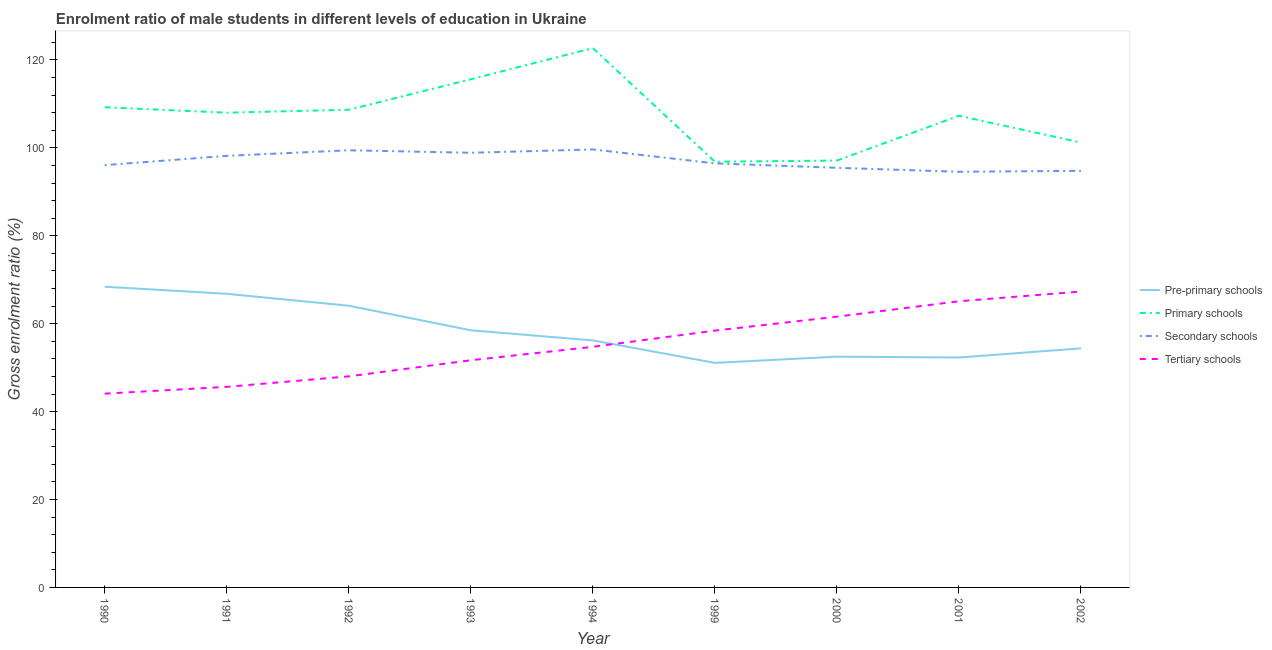Does the line corresponding to gross enrolment ratio(female) in primary schools intersect with the line corresponding to gross enrolment ratio(female) in tertiary schools?
Your answer should be compact. No. What is the gross enrolment ratio(female) in tertiary schools in 2001?
Provide a short and direct response. 65.1. Across all years, what is the maximum gross enrolment ratio(female) in secondary schools?
Ensure brevity in your answer.  99.64. Across all years, what is the minimum gross enrolment ratio(female) in tertiary schools?
Give a very brief answer. 44.09. What is the total gross enrolment ratio(female) in pre-primary schools in the graph?
Your response must be concise. 524.3. What is the difference between the gross enrolment ratio(female) in pre-primary schools in 1990 and that in 1993?
Keep it short and to the point. 9.91. What is the difference between the gross enrolment ratio(female) in tertiary schools in 1992 and the gross enrolment ratio(female) in primary schools in 1991?
Your answer should be very brief. -59.99. What is the average gross enrolment ratio(female) in primary schools per year?
Your response must be concise. 107.41. In the year 1993, what is the difference between the gross enrolment ratio(female) in tertiary schools and gross enrolment ratio(female) in primary schools?
Provide a short and direct response. -63.92. What is the ratio of the gross enrolment ratio(female) in secondary schools in 1991 to that in 2002?
Provide a succinct answer. 1.04. What is the difference between the highest and the second highest gross enrolment ratio(female) in secondary schools?
Your answer should be compact. 0.19. What is the difference between the highest and the lowest gross enrolment ratio(female) in secondary schools?
Your answer should be compact. 5.08. Is it the case that in every year, the sum of the gross enrolment ratio(female) in primary schools and gross enrolment ratio(female) in tertiary schools is greater than the sum of gross enrolment ratio(female) in pre-primary schools and gross enrolment ratio(female) in secondary schools?
Your answer should be compact. Yes. Is the gross enrolment ratio(female) in pre-primary schools strictly greater than the gross enrolment ratio(female) in tertiary schools over the years?
Provide a short and direct response. No. Is the gross enrolment ratio(female) in tertiary schools strictly less than the gross enrolment ratio(female) in pre-primary schools over the years?
Keep it short and to the point. No. How many lines are there?
Provide a short and direct response. 4. How many years are there in the graph?
Your response must be concise. 9. Are the values on the major ticks of Y-axis written in scientific E-notation?
Offer a very short reply. No. Does the graph contain any zero values?
Ensure brevity in your answer.  No. How many legend labels are there?
Give a very brief answer. 4. What is the title of the graph?
Your answer should be compact. Enrolment ratio of male students in different levels of education in Ukraine. Does "Labor Taxes" appear as one of the legend labels in the graph?
Keep it short and to the point. No. What is the label or title of the X-axis?
Offer a terse response. Year. What is the Gross enrolment ratio (%) of Pre-primary schools in 1990?
Provide a short and direct response. 68.42. What is the Gross enrolment ratio (%) of Primary schools in 1990?
Offer a very short reply. 109.24. What is the Gross enrolment ratio (%) of Secondary schools in 1990?
Offer a terse response. 96.07. What is the Gross enrolment ratio (%) of Tertiary schools in 1990?
Provide a succinct answer. 44.09. What is the Gross enrolment ratio (%) in Pre-primary schools in 1991?
Provide a short and direct response. 66.8. What is the Gross enrolment ratio (%) of Primary schools in 1991?
Ensure brevity in your answer.  108.01. What is the Gross enrolment ratio (%) in Secondary schools in 1991?
Provide a succinct answer. 98.19. What is the Gross enrolment ratio (%) in Tertiary schools in 1991?
Provide a succinct answer. 45.63. What is the Gross enrolment ratio (%) of Pre-primary schools in 1992?
Ensure brevity in your answer.  64.09. What is the Gross enrolment ratio (%) of Primary schools in 1992?
Ensure brevity in your answer.  108.67. What is the Gross enrolment ratio (%) in Secondary schools in 1992?
Your response must be concise. 99.45. What is the Gross enrolment ratio (%) in Tertiary schools in 1992?
Provide a succinct answer. 48.02. What is the Gross enrolment ratio (%) in Pre-primary schools in 1993?
Make the answer very short. 58.5. What is the Gross enrolment ratio (%) in Primary schools in 1993?
Your response must be concise. 115.6. What is the Gross enrolment ratio (%) in Secondary schools in 1993?
Your response must be concise. 98.89. What is the Gross enrolment ratio (%) of Tertiary schools in 1993?
Provide a succinct answer. 51.68. What is the Gross enrolment ratio (%) in Pre-primary schools in 1994?
Keep it short and to the point. 56.2. What is the Gross enrolment ratio (%) of Primary schools in 1994?
Keep it short and to the point. 122.7. What is the Gross enrolment ratio (%) in Secondary schools in 1994?
Your response must be concise. 99.64. What is the Gross enrolment ratio (%) of Tertiary schools in 1994?
Offer a very short reply. 54.74. What is the Gross enrolment ratio (%) in Pre-primary schools in 1999?
Your response must be concise. 51.09. What is the Gross enrolment ratio (%) of Primary schools in 1999?
Keep it short and to the point. 96.86. What is the Gross enrolment ratio (%) of Secondary schools in 1999?
Ensure brevity in your answer.  96.48. What is the Gross enrolment ratio (%) of Tertiary schools in 1999?
Your answer should be very brief. 58.43. What is the Gross enrolment ratio (%) in Pre-primary schools in 2000?
Keep it short and to the point. 52.5. What is the Gross enrolment ratio (%) of Primary schools in 2000?
Your answer should be compact. 97.11. What is the Gross enrolment ratio (%) in Secondary schools in 2000?
Provide a short and direct response. 95.46. What is the Gross enrolment ratio (%) in Tertiary schools in 2000?
Make the answer very short. 61.6. What is the Gross enrolment ratio (%) in Pre-primary schools in 2001?
Your response must be concise. 52.31. What is the Gross enrolment ratio (%) of Primary schools in 2001?
Your answer should be very brief. 107.3. What is the Gross enrolment ratio (%) in Secondary schools in 2001?
Your answer should be very brief. 94.56. What is the Gross enrolment ratio (%) in Tertiary schools in 2001?
Keep it short and to the point. 65.1. What is the Gross enrolment ratio (%) in Pre-primary schools in 2002?
Provide a succinct answer. 54.39. What is the Gross enrolment ratio (%) in Primary schools in 2002?
Offer a terse response. 101.22. What is the Gross enrolment ratio (%) of Secondary schools in 2002?
Keep it short and to the point. 94.78. What is the Gross enrolment ratio (%) in Tertiary schools in 2002?
Provide a succinct answer. 67.32. Across all years, what is the maximum Gross enrolment ratio (%) in Pre-primary schools?
Make the answer very short. 68.42. Across all years, what is the maximum Gross enrolment ratio (%) in Primary schools?
Provide a short and direct response. 122.7. Across all years, what is the maximum Gross enrolment ratio (%) of Secondary schools?
Ensure brevity in your answer.  99.64. Across all years, what is the maximum Gross enrolment ratio (%) in Tertiary schools?
Make the answer very short. 67.32. Across all years, what is the minimum Gross enrolment ratio (%) in Pre-primary schools?
Ensure brevity in your answer.  51.09. Across all years, what is the minimum Gross enrolment ratio (%) in Primary schools?
Give a very brief answer. 96.86. Across all years, what is the minimum Gross enrolment ratio (%) of Secondary schools?
Provide a succinct answer. 94.56. Across all years, what is the minimum Gross enrolment ratio (%) in Tertiary schools?
Give a very brief answer. 44.09. What is the total Gross enrolment ratio (%) in Pre-primary schools in the graph?
Your response must be concise. 524.3. What is the total Gross enrolment ratio (%) in Primary schools in the graph?
Provide a short and direct response. 966.7. What is the total Gross enrolment ratio (%) in Secondary schools in the graph?
Provide a short and direct response. 873.52. What is the total Gross enrolment ratio (%) in Tertiary schools in the graph?
Provide a short and direct response. 496.6. What is the difference between the Gross enrolment ratio (%) in Pre-primary schools in 1990 and that in 1991?
Provide a short and direct response. 1.62. What is the difference between the Gross enrolment ratio (%) of Primary schools in 1990 and that in 1991?
Offer a terse response. 1.23. What is the difference between the Gross enrolment ratio (%) in Secondary schools in 1990 and that in 1991?
Make the answer very short. -2.12. What is the difference between the Gross enrolment ratio (%) in Tertiary schools in 1990 and that in 1991?
Ensure brevity in your answer.  -1.54. What is the difference between the Gross enrolment ratio (%) of Pre-primary schools in 1990 and that in 1992?
Ensure brevity in your answer.  4.33. What is the difference between the Gross enrolment ratio (%) in Primary schools in 1990 and that in 1992?
Keep it short and to the point. 0.57. What is the difference between the Gross enrolment ratio (%) of Secondary schools in 1990 and that in 1992?
Give a very brief answer. -3.38. What is the difference between the Gross enrolment ratio (%) of Tertiary schools in 1990 and that in 1992?
Ensure brevity in your answer.  -3.93. What is the difference between the Gross enrolment ratio (%) of Pre-primary schools in 1990 and that in 1993?
Your response must be concise. 9.91. What is the difference between the Gross enrolment ratio (%) of Primary schools in 1990 and that in 1993?
Your answer should be compact. -6.37. What is the difference between the Gross enrolment ratio (%) in Secondary schools in 1990 and that in 1993?
Your answer should be very brief. -2.82. What is the difference between the Gross enrolment ratio (%) of Tertiary schools in 1990 and that in 1993?
Keep it short and to the point. -7.6. What is the difference between the Gross enrolment ratio (%) in Pre-primary schools in 1990 and that in 1994?
Offer a very short reply. 12.21. What is the difference between the Gross enrolment ratio (%) of Primary schools in 1990 and that in 1994?
Provide a short and direct response. -13.46. What is the difference between the Gross enrolment ratio (%) of Secondary schools in 1990 and that in 1994?
Ensure brevity in your answer.  -3.57. What is the difference between the Gross enrolment ratio (%) in Tertiary schools in 1990 and that in 1994?
Your answer should be compact. -10.65. What is the difference between the Gross enrolment ratio (%) of Pre-primary schools in 1990 and that in 1999?
Offer a very short reply. 17.33. What is the difference between the Gross enrolment ratio (%) of Primary schools in 1990 and that in 1999?
Provide a short and direct response. 12.38. What is the difference between the Gross enrolment ratio (%) of Secondary schools in 1990 and that in 1999?
Provide a succinct answer. -0.41. What is the difference between the Gross enrolment ratio (%) in Tertiary schools in 1990 and that in 1999?
Make the answer very short. -14.34. What is the difference between the Gross enrolment ratio (%) of Pre-primary schools in 1990 and that in 2000?
Give a very brief answer. 15.92. What is the difference between the Gross enrolment ratio (%) of Primary schools in 1990 and that in 2000?
Keep it short and to the point. 12.13. What is the difference between the Gross enrolment ratio (%) of Secondary schools in 1990 and that in 2000?
Provide a short and direct response. 0.61. What is the difference between the Gross enrolment ratio (%) in Tertiary schools in 1990 and that in 2000?
Your answer should be very brief. -17.51. What is the difference between the Gross enrolment ratio (%) in Pre-primary schools in 1990 and that in 2001?
Keep it short and to the point. 16.11. What is the difference between the Gross enrolment ratio (%) of Primary schools in 1990 and that in 2001?
Make the answer very short. 1.94. What is the difference between the Gross enrolment ratio (%) in Secondary schools in 1990 and that in 2001?
Provide a succinct answer. 1.51. What is the difference between the Gross enrolment ratio (%) in Tertiary schools in 1990 and that in 2001?
Offer a very short reply. -21.02. What is the difference between the Gross enrolment ratio (%) of Pre-primary schools in 1990 and that in 2002?
Provide a short and direct response. 14.03. What is the difference between the Gross enrolment ratio (%) in Primary schools in 1990 and that in 2002?
Offer a terse response. 8.02. What is the difference between the Gross enrolment ratio (%) in Secondary schools in 1990 and that in 2002?
Offer a very short reply. 1.29. What is the difference between the Gross enrolment ratio (%) of Tertiary schools in 1990 and that in 2002?
Give a very brief answer. -23.23. What is the difference between the Gross enrolment ratio (%) in Pre-primary schools in 1991 and that in 1992?
Ensure brevity in your answer.  2.71. What is the difference between the Gross enrolment ratio (%) of Primary schools in 1991 and that in 1992?
Ensure brevity in your answer.  -0.66. What is the difference between the Gross enrolment ratio (%) of Secondary schools in 1991 and that in 1992?
Ensure brevity in your answer.  -1.27. What is the difference between the Gross enrolment ratio (%) of Tertiary schools in 1991 and that in 1992?
Your answer should be very brief. -2.39. What is the difference between the Gross enrolment ratio (%) in Pre-primary schools in 1991 and that in 1993?
Provide a short and direct response. 8.3. What is the difference between the Gross enrolment ratio (%) of Primary schools in 1991 and that in 1993?
Ensure brevity in your answer.  -7.6. What is the difference between the Gross enrolment ratio (%) in Secondary schools in 1991 and that in 1993?
Provide a short and direct response. -0.7. What is the difference between the Gross enrolment ratio (%) of Tertiary schools in 1991 and that in 1993?
Keep it short and to the point. -6.05. What is the difference between the Gross enrolment ratio (%) in Pre-primary schools in 1991 and that in 1994?
Keep it short and to the point. 10.6. What is the difference between the Gross enrolment ratio (%) in Primary schools in 1991 and that in 1994?
Keep it short and to the point. -14.69. What is the difference between the Gross enrolment ratio (%) of Secondary schools in 1991 and that in 1994?
Make the answer very short. -1.46. What is the difference between the Gross enrolment ratio (%) in Tertiary schools in 1991 and that in 1994?
Offer a terse response. -9.11. What is the difference between the Gross enrolment ratio (%) in Pre-primary schools in 1991 and that in 1999?
Your answer should be compact. 15.71. What is the difference between the Gross enrolment ratio (%) of Primary schools in 1991 and that in 1999?
Your answer should be very brief. 11.15. What is the difference between the Gross enrolment ratio (%) in Secondary schools in 1991 and that in 1999?
Offer a very short reply. 1.71. What is the difference between the Gross enrolment ratio (%) of Tertiary schools in 1991 and that in 1999?
Ensure brevity in your answer.  -12.8. What is the difference between the Gross enrolment ratio (%) of Pre-primary schools in 1991 and that in 2000?
Offer a terse response. 14.3. What is the difference between the Gross enrolment ratio (%) of Primary schools in 1991 and that in 2000?
Ensure brevity in your answer.  10.9. What is the difference between the Gross enrolment ratio (%) of Secondary schools in 1991 and that in 2000?
Offer a very short reply. 2.72. What is the difference between the Gross enrolment ratio (%) in Tertiary schools in 1991 and that in 2000?
Keep it short and to the point. -15.96. What is the difference between the Gross enrolment ratio (%) in Pre-primary schools in 1991 and that in 2001?
Give a very brief answer. 14.49. What is the difference between the Gross enrolment ratio (%) in Primary schools in 1991 and that in 2001?
Offer a terse response. 0.7. What is the difference between the Gross enrolment ratio (%) in Secondary schools in 1991 and that in 2001?
Offer a very short reply. 3.62. What is the difference between the Gross enrolment ratio (%) in Tertiary schools in 1991 and that in 2001?
Your response must be concise. -19.47. What is the difference between the Gross enrolment ratio (%) of Pre-primary schools in 1991 and that in 2002?
Offer a very short reply. 12.41. What is the difference between the Gross enrolment ratio (%) of Primary schools in 1991 and that in 2002?
Offer a terse response. 6.79. What is the difference between the Gross enrolment ratio (%) in Secondary schools in 1991 and that in 2002?
Give a very brief answer. 3.41. What is the difference between the Gross enrolment ratio (%) of Tertiary schools in 1991 and that in 2002?
Keep it short and to the point. -21.69. What is the difference between the Gross enrolment ratio (%) in Pre-primary schools in 1992 and that in 1993?
Your answer should be compact. 5.59. What is the difference between the Gross enrolment ratio (%) of Primary schools in 1992 and that in 1993?
Your answer should be very brief. -6.93. What is the difference between the Gross enrolment ratio (%) in Secondary schools in 1992 and that in 1993?
Make the answer very short. 0.57. What is the difference between the Gross enrolment ratio (%) of Tertiary schools in 1992 and that in 1993?
Give a very brief answer. -3.67. What is the difference between the Gross enrolment ratio (%) in Pre-primary schools in 1992 and that in 1994?
Provide a short and direct response. 7.89. What is the difference between the Gross enrolment ratio (%) in Primary schools in 1992 and that in 1994?
Offer a very short reply. -14.03. What is the difference between the Gross enrolment ratio (%) in Secondary schools in 1992 and that in 1994?
Give a very brief answer. -0.19. What is the difference between the Gross enrolment ratio (%) in Tertiary schools in 1992 and that in 1994?
Keep it short and to the point. -6.72. What is the difference between the Gross enrolment ratio (%) in Pre-primary schools in 1992 and that in 1999?
Give a very brief answer. 13. What is the difference between the Gross enrolment ratio (%) of Primary schools in 1992 and that in 1999?
Give a very brief answer. 11.81. What is the difference between the Gross enrolment ratio (%) of Secondary schools in 1992 and that in 1999?
Your response must be concise. 2.98. What is the difference between the Gross enrolment ratio (%) in Tertiary schools in 1992 and that in 1999?
Your answer should be very brief. -10.41. What is the difference between the Gross enrolment ratio (%) in Pre-primary schools in 1992 and that in 2000?
Make the answer very short. 11.59. What is the difference between the Gross enrolment ratio (%) of Primary schools in 1992 and that in 2000?
Your answer should be very brief. 11.56. What is the difference between the Gross enrolment ratio (%) in Secondary schools in 1992 and that in 2000?
Your answer should be compact. 3.99. What is the difference between the Gross enrolment ratio (%) in Tertiary schools in 1992 and that in 2000?
Keep it short and to the point. -13.58. What is the difference between the Gross enrolment ratio (%) in Pre-primary schools in 1992 and that in 2001?
Offer a terse response. 11.78. What is the difference between the Gross enrolment ratio (%) in Primary schools in 1992 and that in 2001?
Provide a succinct answer. 1.37. What is the difference between the Gross enrolment ratio (%) in Secondary schools in 1992 and that in 2001?
Your answer should be compact. 4.89. What is the difference between the Gross enrolment ratio (%) of Tertiary schools in 1992 and that in 2001?
Ensure brevity in your answer.  -17.09. What is the difference between the Gross enrolment ratio (%) of Pre-primary schools in 1992 and that in 2002?
Provide a succinct answer. 9.7. What is the difference between the Gross enrolment ratio (%) of Primary schools in 1992 and that in 2002?
Keep it short and to the point. 7.46. What is the difference between the Gross enrolment ratio (%) in Secondary schools in 1992 and that in 2002?
Make the answer very short. 4.68. What is the difference between the Gross enrolment ratio (%) in Tertiary schools in 1992 and that in 2002?
Keep it short and to the point. -19.3. What is the difference between the Gross enrolment ratio (%) of Pre-primary schools in 1993 and that in 1994?
Your answer should be very brief. 2.3. What is the difference between the Gross enrolment ratio (%) in Primary schools in 1993 and that in 1994?
Provide a short and direct response. -7.09. What is the difference between the Gross enrolment ratio (%) in Secondary schools in 1993 and that in 1994?
Offer a very short reply. -0.76. What is the difference between the Gross enrolment ratio (%) in Tertiary schools in 1993 and that in 1994?
Provide a succinct answer. -3.06. What is the difference between the Gross enrolment ratio (%) in Pre-primary schools in 1993 and that in 1999?
Make the answer very short. 7.41. What is the difference between the Gross enrolment ratio (%) of Primary schools in 1993 and that in 1999?
Provide a short and direct response. 18.75. What is the difference between the Gross enrolment ratio (%) in Secondary schools in 1993 and that in 1999?
Provide a short and direct response. 2.41. What is the difference between the Gross enrolment ratio (%) of Tertiary schools in 1993 and that in 1999?
Offer a very short reply. -6.74. What is the difference between the Gross enrolment ratio (%) of Pre-primary schools in 1993 and that in 2000?
Provide a succinct answer. 6. What is the difference between the Gross enrolment ratio (%) of Primary schools in 1993 and that in 2000?
Your answer should be compact. 18.49. What is the difference between the Gross enrolment ratio (%) of Secondary schools in 1993 and that in 2000?
Your answer should be very brief. 3.42. What is the difference between the Gross enrolment ratio (%) of Tertiary schools in 1993 and that in 2000?
Provide a succinct answer. -9.91. What is the difference between the Gross enrolment ratio (%) of Pre-primary schools in 1993 and that in 2001?
Offer a very short reply. 6.19. What is the difference between the Gross enrolment ratio (%) in Primary schools in 1993 and that in 2001?
Your answer should be compact. 8.3. What is the difference between the Gross enrolment ratio (%) of Secondary schools in 1993 and that in 2001?
Ensure brevity in your answer.  4.32. What is the difference between the Gross enrolment ratio (%) of Tertiary schools in 1993 and that in 2001?
Your response must be concise. -13.42. What is the difference between the Gross enrolment ratio (%) in Pre-primary schools in 1993 and that in 2002?
Keep it short and to the point. 4.11. What is the difference between the Gross enrolment ratio (%) of Primary schools in 1993 and that in 2002?
Offer a terse response. 14.39. What is the difference between the Gross enrolment ratio (%) of Secondary schools in 1993 and that in 2002?
Provide a succinct answer. 4.11. What is the difference between the Gross enrolment ratio (%) in Tertiary schools in 1993 and that in 2002?
Your answer should be compact. -15.64. What is the difference between the Gross enrolment ratio (%) in Pre-primary schools in 1994 and that in 1999?
Make the answer very short. 5.12. What is the difference between the Gross enrolment ratio (%) in Primary schools in 1994 and that in 1999?
Keep it short and to the point. 25.84. What is the difference between the Gross enrolment ratio (%) of Secondary schools in 1994 and that in 1999?
Ensure brevity in your answer.  3.17. What is the difference between the Gross enrolment ratio (%) of Tertiary schools in 1994 and that in 1999?
Your response must be concise. -3.69. What is the difference between the Gross enrolment ratio (%) in Pre-primary schools in 1994 and that in 2000?
Provide a succinct answer. 3.7. What is the difference between the Gross enrolment ratio (%) of Primary schools in 1994 and that in 2000?
Offer a terse response. 25.59. What is the difference between the Gross enrolment ratio (%) in Secondary schools in 1994 and that in 2000?
Offer a terse response. 4.18. What is the difference between the Gross enrolment ratio (%) in Tertiary schools in 1994 and that in 2000?
Provide a short and direct response. -6.86. What is the difference between the Gross enrolment ratio (%) of Pre-primary schools in 1994 and that in 2001?
Your answer should be very brief. 3.89. What is the difference between the Gross enrolment ratio (%) of Primary schools in 1994 and that in 2001?
Make the answer very short. 15.4. What is the difference between the Gross enrolment ratio (%) of Secondary schools in 1994 and that in 2001?
Give a very brief answer. 5.08. What is the difference between the Gross enrolment ratio (%) of Tertiary schools in 1994 and that in 2001?
Offer a terse response. -10.37. What is the difference between the Gross enrolment ratio (%) of Pre-primary schools in 1994 and that in 2002?
Your response must be concise. 1.82. What is the difference between the Gross enrolment ratio (%) in Primary schools in 1994 and that in 2002?
Offer a very short reply. 21.48. What is the difference between the Gross enrolment ratio (%) of Secondary schools in 1994 and that in 2002?
Make the answer very short. 4.87. What is the difference between the Gross enrolment ratio (%) in Tertiary schools in 1994 and that in 2002?
Your answer should be very brief. -12.58. What is the difference between the Gross enrolment ratio (%) of Pre-primary schools in 1999 and that in 2000?
Keep it short and to the point. -1.41. What is the difference between the Gross enrolment ratio (%) of Primary schools in 1999 and that in 2000?
Provide a short and direct response. -0.25. What is the difference between the Gross enrolment ratio (%) in Secondary schools in 1999 and that in 2000?
Provide a succinct answer. 1.01. What is the difference between the Gross enrolment ratio (%) in Tertiary schools in 1999 and that in 2000?
Offer a very short reply. -3.17. What is the difference between the Gross enrolment ratio (%) of Pre-primary schools in 1999 and that in 2001?
Offer a very short reply. -1.22. What is the difference between the Gross enrolment ratio (%) in Primary schools in 1999 and that in 2001?
Provide a succinct answer. -10.45. What is the difference between the Gross enrolment ratio (%) in Secondary schools in 1999 and that in 2001?
Offer a terse response. 1.91. What is the difference between the Gross enrolment ratio (%) in Tertiary schools in 1999 and that in 2001?
Your response must be concise. -6.68. What is the difference between the Gross enrolment ratio (%) of Pre-primary schools in 1999 and that in 2002?
Keep it short and to the point. -3.3. What is the difference between the Gross enrolment ratio (%) in Primary schools in 1999 and that in 2002?
Your response must be concise. -4.36. What is the difference between the Gross enrolment ratio (%) in Secondary schools in 1999 and that in 2002?
Offer a terse response. 1.7. What is the difference between the Gross enrolment ratio (%) in Tertiary schools in 1999 and that in 2002?
Provide a short and direct response. -8.89. What is the difference between the Gross enrolment ratio (%) of Pre-primary schools in 2000 and that in 2001?
Make the answer very short. 0.19. What is the difference between the Gross enrolment ratio (%) of Primary schools in 2000 and that in 2001?
Give a very brief answer. -10.19. What is the difference between the Gross enrolment ratio (%) of Secondary schools in 2000 and that in 2001?
Provide a short and direct response. 0.9. What is the difference between the Gross enrolment ratio (%) in Tertiary schools in 2000 and that in 2001?
Your answer should be very brief. -3.51. What is the difference between the Gross enrolment ratio (%) of Pre-primary schools in 2000 and that in 2002?
Your response must be concise. -1.89. What is the difference between the Gross enrolment ratio (%) in Primary schools in 2000 and that in 2002?
Your answer should be compact. -4.11. What is the difference between the Gross enrolment ratio (%) of Secondary schools in 2000 and that in 2002?
Ensure brevity in your answer.  0.69. What is the difference between the Gross enrolment ratio (%) of Tertiary schools in 2000 and that in 2002?
Your answer should be very brief. -5.73. What is the difference between the Gross enrolment ratio (%) of Pre-primary schools in 2001 and that in 2002?
Provide a short and direct response. -2.08. What is the difference between the Gross enrolment ratio (%) in Primary schools in 2001 and that in 2002?
Your answer should be very brief. 6.09. What is the difference between the Gross enrolment ratio (%) of Secondary schools in 2001 and that in 2002?
Offer a very short reply. -0.21. What is the difference between the Gross enrolment ratio (%) in Tertiary schools in 2001 and that in 2002?
Your answer should be very brief. -2.22. What is the difference between the Gross enrolment ratio (%) of Pre-primary schools in 1990 and the Gross enrolment ratio (%) of Primary schools in 1991?
Make the answer very short. -39.59. What is the difference between the Gross enrolment ratio (%) of Pre-primary schools in 1990 and the Gross enrolment ratio (%) of Secondary schools in 1991?
Your response must be concise. -29.77. What is the difference between the Gross enrolment ratio (%) of Pre-primary schools in 1990 and the Gross enrolment ratio (%) of Tertiary schools in 1991?
Provide a short and direct response. 22.79. What is the difference between the Gross enrolment ratio (%) of Primary schools in 1990 and the Gross enrolment ratio (%) of Secondary schools in 1991?
Your response must be concise. 11.05. What is the difference between the Gross enrolment ratio (%) of Primary schools in 1990 and the Gross enrolment ratio (%) of Tertiary schools in 1991?
Keep it short and to the point. 63.61. What is the difference between the Gross enrolment ratio (%) in Secondary schools in 1990 and the Gross enrolment ratio (%) in Tertiary schools in 1991?
Provide a short and direct response. 50.44. What is the difference between the Gross enrolment ratio (%) of Pre-primary schools in 1990 and the Gross enrolment ratio (%) of Primary schools in 1992?
Provide a succinct answer. -40.25. What is the difference between the Gross enrolment ratio (%) of Pre-primary schools in 1990 and the Gross enrolment ratio (%) of Secondary schools in 1992?
Your response must be concise. -31.04. What is the difference between the Gross enrolment ratio (%) in Pre-primary schools in 1990 and the Gross enrolment ratio (%) in Tertiary schools in 1992?
Make the answer very short. 20.4. What is the difference between the Gross enrolment ratio (%) of Primary schools in 1990 and the Gross enrolment ratio (%) of Secondary schools in 1992?
Ensure brevity in your answer.  9.79. What is the difference between the Gross enrolment ratio (%) of Primary schools in 1990 and the Gross enrolment ratio (%) of Tertiary schools in 1992?
Your answer should be very brief. 61.22. What is the difference between the Gross enrolment ratio (%) of Secondary schools in 1990 and the Gross enrolment ratio (%) of Tertiary schools in 1992?
Your response must be concise. 48.05. What is the difference between the Gross enrolment ratio (%) in Pre-primary schools in 1990 and the Gross enrolment ratio (%) in Primary schools in 1993?
Your response must be concise. -47.19. What is the difference between the Gross enrolment ratio (%) of Pre-primary schools in 1990 and the Gross enrolment ratio (%) of Secondary schools in 1993?
Offer a very short reply. -30.47. What is the difference between the Gross enrolment ratio (%) of Pre-primary schools in 1990 and the Gross enrolment ratio (%) of Tertiary schools in 1993?
Make the answer very short. 16.73. What is the difference between the Gross enrolment ratio (%) of Primary schools in 1990 and the Gross enrolment ratio (%) of Secondary schools in 1993?
Provide a short and direct response. 10.35. What is the difference between the Gross enrolment ratio (%) in Primary schools in 1990 and the Gross enrolment ratio (%) in Tertiary schools in 1993?
Provide a short and direct response. 57.56. What is the difference between the Gross enrolment ratio (%) of Secondary schools in 1990 and the Gross enrolment ratio (%) of Tertiary schools in 1993?
Your answer should be very brief. 44.39. What is the difference between the Gross enrolment ratio (%) in Pre-primary schools in 1990 and the Gross enrolment ratio (%) in Primary schools in 1994?
Your answer should be very brief. -54.28. What is the difference between the Gross enrolment ratio (%) of Pre-primary schools in 1990 and the Gross enrolment ratio (%) of Secondary schools in 1994?
Give a very brief answer. -31.23. What is the difference between the Gross enrolment ratio (%) in Pre-primary schools in 1990 and the Gross enrolment ratio (%) in Tertiary schools in 1994?
Offer a terse response. 13.68. What is the difference between the Gross enrolment ratio (%) of Primary schools in 1990 and the Gross enrolment ratio (%) of Secondary schools in 1994?
Keep it short and to the point. 9.59. What is the difference between the Gross enrolment ratio (%) of Primary schools in 1990 and the Gross enrolment ratio (%) of Tertiary schools in 1994?
Ensure brevity in your answer.  54.5. What is the difference between the Gross enrolment ratio (%) of Secondary schools in 1990 and the Gross enrolment ratio (%) of Tertiary schools in 1994?
Offer a terse response. 41.33. What is the difference between the Gross enrolment ratio (%) in Pre-primary schools in 1990 and the Gross enrolment ratio (%) in Primary schools in 1999?
Provide a short and direct response. -28.44. What is the difference between the Gross enrolment ratio (%) of Pre-primary schools in 1990 and the Gross enrolment ratio (%) of Secondary schools in 1999?
Your answer should be very brief. -28.06. What is the difference between the Gross enrolment ratio (%) in Pre-primary schools in 1990 and the Gross enrolment ratio (%) in Tertiary schools in 1999?
Your answer should be very brief. 9.99. What is the difference between the Gross enrolment ratio (%) of Primary schools in 1990 and the Gross enrolment ratio (%) of Secondary schools in 1999?
Offer a terse response. 12.76. What is the difference between the Gross enrolment ratio (%) in Primary schools in 1990 and the Gross enrolment ratio (%) in Tertiary schools in 1999?
Your answer should be very brief. 50.81. What is the difference between the Gross enrolment ratio (%) in Secondary schools in 1990 and the Gross enrolment ratio (%) in Tertiary schools in 1999?
Make the answer very short. 37.64. What is the difference between the Gross enrolment ratio (%) of Pre-primary schools in 1990 and the Gross enrolment ratio (%) of Primary schools in 2000?
Your response must be concise. -28.69. What is the difference between the Gross enrolment ratio (%) of Pre-primary schools in 1990 and the Gross enrolment ratio (%) of Secondary schools in 2000?
Offer a very short reply. -27.05. What is the difference between the Gross enrolment ratio (%) of Pre-primary schools in 1990 and the Gross enrolment ratio (%) of Tertiary schools in 2000?
Keep it short and to the point. 6.82. What is the difference between the Gross enrolment ratio (%) of Primary schools in 1990 and the Gross enrolment ratio (%) of Secondary schools in 2000?
Your response must be concise. 13.77. What is the difference between the Gross enrolment ratio (%) in Primary schools in 1990 and the Gross enrolment ratio (%) in Tertiary schools in 2000?
Your response must be concise. 47.64. What is the difference between the Gross enrolment ratio (%) of Secondary schools in 1990 and the Gross enrolment ratio (%) of Tertiary schools in 2000?
Give a very brief answer. 34.47. What is the difference between the Gross enrolment ratio (%) in Pre-primary schools in 1990 and the Gross enrolment ratio (%) in Primary schools in 2001?
Make the answer very short. -38.89. What is the difference between the Gross enrolment ratio (%) in Pre-primary schools in 1990 and the Gross enrolment ratio (%) in Secondary schools in 2001?
Offer a very short reply. -26.15. What is the difference between the Gross enrolment ratio (%) of Pre-primary schools in 1990 and the Gross enrolment ratio (%) of Tertiary schools in 2001?
Your answer should be very brief. 3.31. What is the difference between the Gross enrolment ratio (%) in Primary schools in 1990 and the Gross enrolment ratio (%) in Secondary schools in 2001?
Give a very brief answer. 14.67. What is the difference between the Gross enrolment ratio (%) of Primary schools in 1990 and the Gross enrolment ratio (%) of Tertiary schools in 2001?
Offer a terse response. 44.13. What is the difference between the Gross enrolment ratio (%) in Secondary schools in 1990 and the Gross enrolment ratio (%) in Tertiary schools in 2001?
Your answer should be compact. 30.97. What is the difference between the Gross enrolment ratio (%) of Pre-primary schools in 1990 and the Gross enrolment ratio (%) of Primary schools in 2002?
Give a very brief answer. -32.8. What is the difference between the Gross enrolment ratio (%) of Pre-primary schools in 1990 and the Gross enrolment ratio (%) of Secondary schools in 2002?
Provide a short and direct response. -26.36. What is the difference between the Gross enrolment ratio (%) of Pre-primary schools in 1990 and the Gross enrolment ratio (%) of Tertiary schools in 2002?
Ensure brevity in your answer.  1.1. What is the difference between the Gross enrolment ratio (%) in Primary schools in 1990 and the Gross enrolment ratio (%) in Secondary schools in 2002?
Keep it short and to the point. 14.46. What is the difference between the Gross enrolment ratio (%) of Primary schools in 1990 and the Gross enrolment ratio (%) of Tertiary schools in 2002?
Give a very brief answer. 41.92. What is the difference between the Gross enrolment ratio (%) in Secondary schools in 1990 and the Gross enrolment ratio (%) in Tertiary schools in 2002?
Offer a terse response. 28.75. What is the difference between the Gross enrolment ratio (%) of Pre-primary schools in 1991 and the Gross enrolment ratio (%) of Primary schools in 1992?
Make the answer very short. -41.87. What is the difference between the Gross enrolment ratio (%) in Pre-primary schools in 1991 and the Gross enrolment ratio (%) in Secondary schools in 1992?
Your answer should be very brief. -32.65. What is the difference between the Gross enrolment ratio (%) of Pre-primary schools in 1991 and the Gross enrolment ratio (%) of Tertiary schools in 1992?
Your answer should be very brief. 18.78. What is the difference between the Gross enrolment ratio (%) of Primary schools in 1991 and the Gross enrolment ratio (%) of Secondary schools in 1992?
Provide a succinct answer. 8.55. What is the difference between the Gross enrolment ratio (%) of Primary schools in 1991 and the Gross enrolment ratio (%) of Tertiary schools in 1992?
Provide a succinct answer. 59.99. What is the difference between the Gross enrolment ratio (%) in Secondary schools in 1991 and the Gross enrolment ratio (%) in Tertiary schools in 1992?
Offer a terse response. 50.17. What is the difference between the Gross enrolment ratio (%) of Pre-primary schools in 1991 and the Gross enrolment ratio (%) of Primary schools in 1993?
Your response must be concise. -48.8. What is the difference between the Gross enrolment ratio (%) in Pre-primary schools in 1991 and the Gross enrolment ratio (%) in Secondary schools in 1993?
Make the answer very short. -32.09. What is the difference between the Gross enrolment ratio (%) in Pre-primary schools in 1991 and the Gross enrolment ratio (%) in Tertiary schools in 1993?
Provide a short and direct response. 15.12. What is the difference between the Gross enrolment ratio (%) in Primary schools in 1991 and the Gross enrolment ratio (%) in Secondary schools in 1993?
Keep it short and to the point. 9.12. What is the difference between the Gross enrolment ratio (%) in Primary schools in 1991 and the Gross enrolment ratio (%) in Tertiary schools in 1993?
Provide a short and direct response. 56.32. What is the difference between the Gross enrolment ratio (%) in Secondary schools in 1991 and the Gross enrolment ratio (%) in Tertiary schools in 1993?
Your answer should be very brief. 46.5. What is the difference between the Gross enrolment ratio (%) of Pre-primary schools in 1991 and the Gross enrolment ratio (%) of Primary schools in 1994?
Ensure brevity in your answer.  -55.9. What is the difference between the Gross enrolment ratio (%) in Pre-primary schools in 1991 and the Gross enrolment ratio (%) in Secondary schools in 1994?
Ensure brevity in your answer.  -32.84. What is the difference between the Gross enrolment ratio (%) in Pre-primary schools in 1991 and the Gross enrolment ratio (%) in Tertiary schools in 1994?
Give a very brief answer. 12.06. What is the difference between the Gross enrolment ratio (%) in Primary schools in 1991 and the Gross enrolment ratio (%) in Secondary schools in 1994?
Make the answer very short. 8.36. What is the difference between the Gross enrolment ratio (%) of Primary schools in 1991 and the Gross enrolment ratio (%) of Tertiary schools in 1994?
Keep it short and to the point. 53.27. What is the difference between the Gross enrolment ratio (%) of Secondary schools in 1991 and the Gross enrolment ratio (%) of Tertiary schools in 1994?
Provide a succinct answer. 43.45. What is the difference between the Gross enrolment ratio (%) of Pre-primary schools in 1991 and the Gross enrolment ratio (%) of Primary schools in 1999?
Keep it short and to the point. -30.06. What is the difference between the Gross enrolment ratio (%) of Pre-primary schools in 1991 and the Gross enrolment ratio (%) of Secondary schools in 1999?
Make the answer very short. -29.68. What is the difference between the Gross enrolment ratio (%) in Pre-primary schools in 1991 and the Gross enrolment ratio (%) in Tertiary schools in 1999?
Your answer should be compact. 8.37. What is the difference between the Gross enrolment ratio (%) in Primary schools in 1991 and the Gross enrolment ratio (%) in Secondary schools in 1999?
Your answer should be very brief. 11.53. What is the difference between the Gross enrolment ratio (%) of Primary schools in 1991 and the Gross enrolment ratio (%) of Tertiary schools in 1999?
Offer a terse response. 49.58. What is the difference between the Gross enrolment ratio (%) in Secondary schools in 1991 and the Gross enrolment ratio (%) in Tertiary schools in 1999?
Your answer should be compact. 39.76. What is the difference between the Gross enrolment ratio (%) of Pre-primary schools in 1991 and the Gross enrolment ratio (%) of Primary schools in 2000?
Offer a very short reply. -30.31. What is the difference between the Gross enrolment ratio (%) in Pre-primary schools in 1991 and the Gross enrolment ratio (%) in Secondary schools in 2000?
Offer a very short reply. -28.66. What is the difference between the Gross enrolment ratio (%) of Pre-primary schools in 1991 and the Gross enrolment ratio (%) of Tertiary schools in 2000?
Provide a short and direct response. 5.2. What is the difference between the Gross enrolment ratio (%) of Primary schools in 1991 and the Gross enrolment ratio (%) of Secondary schools in 2000?
Your response must be concise. 12.54. What is the difference between the Gross enrolment ratio (%) of Primary schools in 1991 and the Gross enrolment ratio (%) of Tertiary schools in 2000?
Make the answer very short. 46.41. What is the difference between the Gross enrolment ratio (%) of Secondary schools in 1991 and the Gross enrolment ratio (%) of Tertiary schools in 2000?
Your response must be concise. 36.59. What is the difference between the Gross enrolment ratio (%) in Pre-primary schools in 1991 and the Gross enrolment ratio (%) in Primary schools in 2001?
Offer a terse response. -40.5. What is the difference between the Gross enrolment ratio (%) in Pre-primary schools in 1991 and the Gross enrolment ratio (%) in Secondary schools in 2001?
Your response must be concise. -27.76. What is the difference between the Gross enrolment ratio (%) of Pre-primary schools in 1991 and the Gross enrolment ratio (%) of Tertiary schools in 2001?
Your answer should be very brief. 1.7. What is the difference between the Gross enrolment ratio (%) in Primary schools in 1991 and the Gross enrolment ratio (%) in Secondary schools in 2001?
Your answer should be very brief. 13.44. What is the difference between the Gross enrolment ratio (%) of Primary schools in 1991 and the Gross enrolment ratio (%) of Tertiary schools in 2001?
Your answer should be very brief. 42.9. What is the difference between the Gross enrolment ratio (%) of Secondary schools in 1991 and the Gross enrolment ratio (%) of Tertiary schools in 2001?
Keep it short and to the point. 33.08. What is the difference between the Gross enrolment ratio (%) of Pre-primary schools in 1991 and the Gross enrolment ratio (%) of Primary schools in 2002?
Provide a succinct answer. -34.41. What is the difference between the Gross enrolment ratio (%) in Pre-primary schools in 1991 and the Gross enrolment ratio (%) in Secondary schools in 2002?
Ensure brevity in your answer.  -27.98. What is the difference between the Gross enrolment ratio (%) of Pre-primary schools in 1991 and the Gross enrolment ratio (%) of Tertiary schools in 2002?
Make the answer very short. -0.52. What is the difference between the Gross enrolment ratio (%) in Primary schools in 1991 and the Gross enrolment ratio (%) in Secondary schools in 2002?
Give a very brief answer. 13.23. What is the difference between the Gross enrolment ratio (%) in Primary schools in 1991 and the Gross enrolment ratio (%) in Tertiary schools in 2002?
Give a very brief answer. 40.69. What is the difference between the Gross enrolment ratio (%) in Secondary schools in 1991 and the Gross enrolment ratio (%) in Tertiary schools in 2002?
Keep it short and to the point. 30.87. What is the difference between the Gross enrolment ratio (%) of Pre-primary schools in 1992 and the Gross enrolment ratio (%) of Primary schools in 1993?
Your answer should be very brief. -51.51. What is the difference between the Gross enrolment ratio (%) of Pre-primary schools in 1992 and the Gross enrolment ratio (%) of Secondary schools in 1993?
Provide a succinct answer. -34.8. What is the difference between the Gross enrolment ratio (%) of Pre-primary schools in 1992 and the Gross enrolment ratio (%) of Tertiary schools in 1993?
Give a very brief answer. 12.41. What is the difference between the Gross enrolment ratio (%) of Primary schools in 1992 and the Gross enrolment ratio (%) of Secondary schools in 1993?
Your answer should be very brief. 9.78. What is the difference between the Gross enrolment ratio (%) in Primary schools in 1992 and the Gross enrolment ratio (%) in Tertiary schools in 1993?
Provide a succinct answer. 56.99. What is the difference between the Gross enrolment ratio (%) of Secondary schools in 1992 and the Gross enrolment ratio (%) of Tertiary schools in 1993?
Keep it short and to the point. 47.77. What is the difference between the Gross enrolment ratio (%) of Pre-primary schools in 1992 and the Gross enrolment ratio (%) of Primary schools in 1994?
Ensure brevity in your answer.  -58.61. What is the difference between the Gross enrolment ratio (%) of Pre-primary schools in 1992 and the Gross enrolment ratio (%) of Secondary schools in 1994?
Give a very brief answer. -35.55. What is the difference between the Gross enrolment ratio (%) in Pre-primary schools in 1992 and the Gross enrolment ratio (%) in Tertiary schools in 1994?
Keep it short and to the point. 9.35. What is the difference between the Gross enrolment ratio (%) in Primary schools in 1992 and the Gross enrolment ratio (%) in Secondary schools in 1994?
Provide a short and direct response. 9.03. What is the difference between the Gross enrolment ratio (%) in Primary schools in 1992 and the Gross enrolment ratio (%) in Tertiary schools in 1994?
Offer a terse response. 53.93. What is the difference between the Gross enrolment ratio (%) in Secondary schools in 1992 and the Gross enrolment ratio (%) in Tertiary schools in 1994?
Provide a succinct answer. 44.71. What is the difference between the Gross enrolment ratio (%) in Pre-primary schools in 1992 and the Gross enrolment ratio (%) in Primary schools in 1999?
Offer a terse response. -32.77. What is the difference between the Gross enrolment ratio (%) in Pre-primary schools in 1992 and the Gross enrolment ratio (%) in Secondary schools in 1999?
Provide a short and direct response. -32.39. What is the difference between the Gross enrolment ratio (%) in Pre-primary schools in 1992 and the Gross enrolment ratio (%) in Tertiary schools in 1999?
Offer a terse response. 5.66. What is the difference between the Gross enrolment ratio (%) of Primary schools in 1992 and the Gross enrolment ratio (%) of Secondary schools in 1999?
Make the answer very short. 12.19. What is the difference between the Gross enrolment ratio (%) in Primary schools in 1992 and the Gross enrolment ratio (%) in Tertiary schools in 1999?
Provide a succinct answer. 50.24. What is the difference between the Gross enrolment ratio (%) in Secondary schools in 1992 and the Gross enrolment ratio (%) in Tertiary schools in 1999?
Keep it short and to the point. 41.03. What is the difference between the Gross enrolment ratio (%) in Pre-primary schools in 1992 and the Gross enrolment ratio (%) in Primary schools in 2000?
Offer a very short reply. -33.02. What is the difference between the Gross enrolment ratio (%) in Pre-primary schools in 1992 and the Gross enrolment ratio (%) in Secondary schools in 2000?
Keep it short and to the point. -31.38. What is the difference between the Gross enrolment ratio (%) of Pre-primary schools in 1992 and the Gross enrolment ratio (%) of Tertiary schools in 2000?
Offer a very short reply. 2.49. What is the difference between the Gross enrolment ratio (%) of Primary schools in 1992 and the Gross enrolment ratio (%) of Secondary schools in 2000?
Offer a very short reply. 13.21. What is the difference between the Gross enrolment ratio (%) in Primary schools in 1992 and the Gross enrolment ratio (%) in Tertiary schools in 2000?
Keep it short and to the point. 47.07. What is the difference between the Gross enrolment ratio (%) of Secondary schools in 1992 and the Gross enrolment ratio (%) of Tertiary schools in 2000?
Your answer should be very brief. 37.86. What is the difference between the Gross enrolment ratio (%) of Pre-primary schools in 1992 and the Gross enrolment ratio (%) of Primary schools in 2001?
Provide a short and direct response. -43.21. What is the difference between the Gross enrolment ratio (%) of Pre-primary schools in 1992 and the Gross enrolment ratio (%) of Secondary schools in 2001?
Make the answer very short. -30.48. What is the difference between the Gross enrolment ratio (%) of Pre-primary schools in 1992 and the Gross enrolment ratio (%) of Tertiary schools in 2001?
Keep it short and to the point. -1.02. What is the difference between the Gross enrolment ratio (%) in Primary schools in 1992 and the Gross enrolment ratio (%) in Secondary schools in 2001?
Offer a very short reply. 14.11. What is the difference between the Gross enrolment ratio (%) in Primary schools in 1992 and the Gross enrolment ratio (%) in Tertiary schools in 2001?
Ensure brevity in your answer.  43.57. What is the difference between the Gross enrolment ratio (%) in Secondary schools in 1992 and the Gross enrolment ratio (%) in Tertiary schools in 2001?
Your answer should be compact. 34.35. What is the difference between the Gross enrolment ratio (%) in Pre-primary schools in 1992 and the Gross enrolment ratio (%) in Primary schools in 2002?
Your answer should be very brief. -37.13. What is the difference between the Gross enrolment ratio (%) of Pre-primary schools in 1992 and the Gross enrolment ratio (%) of Secondary schools in 2002?
Make the answer very short. -30.69. What is the difference between the Gross enrolment ratio (%) of Pre-primary schools in 1992 and the Gross enrolment ratio (%) of Tertiary schools in 2002?
Ensure brevity in your answer.  -3.23. What is the difference between the Gross enrolment ratio (%) of Primary schools in 1992 and the Gross enrolment ratio (%) of Secondary schools in 2002?
Make the answer very short. 13.89. What is the difference between the Gross enrolment ratio (%) in Primary schools in 1992 and the Gross enrolment ratio (%) in Tertiary schools in 2002?
Keep it short and to the point. 41.35. What is the difference between the Gross enrolment ratio (%) in Secondary schools in 1992 and the Gross enrolment ratio (%) in Tertiary schools in 2002?
Your response must be concise. 32.13. What is the difference between the Gross enrolment ratio (%) of Pre-primary schools in 1993 and the Gross enrolment ratio (%) of Primary schools in 1994?
Offer a terse response. -64.2. What is the difference between the Gross enrolment ratio (%) of Pre-primary schools in 1993 and the Gross enrolment ratio (%) of Secondary schools in 1994?
Offer a very short reply. -41.14. What is the difference between the Gross enrolment ratio (%) in Pre-primary schools in 1993 and the Gross enrolment ratio (%) in Tertiary schools in 1994?
Offer a very short reply. 3.76. What is the difference between the Gross enrolment ratio (%) of Primary schools in 1993 and the Gross enrolment ratio (%) of Secondary schools in 1994?
Ensure brevity in your answer.  15.96. What is the difference between the Gross enrolment ratio (%) of Primary schools in 1993 and the Gross enrolment ratio (%) of Tertiary schools in 1994?
Ensure brevity in your answer.  60.87. What is the difference between the Gross enrolment ratio (%) of Secondary schools in 1993 and the Gross enrolment ratio (%) of Tertiary schools in 1994?
Your response must be concise. 44.15. What is the difference between the Gross enrolment ratio (%) in Pre-primary schools in 1993 and the Gross enrolment ratio (%) in Primary schools in 1999?
Ensure brevity in your answer.  -38.36. What is the difference between the Gross enrolment ratio (%) of Pre-primary schools in 1993 and the Gross enrolment ratio (%) of Secondary schools in 1999?
Offer a very short reply. -37.97. What is the difference between the Gross enrolment ratio (%) in Pre-primary schools in 1993 and the Gross enrolment ratio (%) in Tertiary schools in 1999?
Offer a very short reply. 0.07. What is the difference between the Gross enrolment ratio (%) of Primary schools in 1993 and the Gross enrolment ratio (%) of Secondary schools in 1999?
Your answer should be very brief. 19.13. What is the difference between the Gross enrolment ratio (%) in Primary schools in 1993 and the Gross enrolment ratio (%) in Tertiary schools in 1999?
Make the answer very short. 57.18. What is the difference between the Gross enrolment ratio (%) of Secondary schools in 1993 and the Gross enrolment ratio (%) of Tertiary schools in 1999?
Give a very brief answer. 40.46. What is the difference between the Gross enrolment ratio (%) in Pre-primary schools in 1993 and the Gross enrolment ratio (%) in Primary schools in 2000?
Give a very brief answer. -38.61. What is the difference between the Gross enrolment ratio (%) in Pre-primary schools in 1993 and the Gross enrolment ratio (%) in Secondary schools in 2000?
Offer a terse response. -36.96. What is the difference between the Gross enrolment ratio (%) in Pre-primary schools in 1993 and the Gross enrolment ratio (%) in Tertiary schools in 2000?
Provide a succinct answer. -3.09. What is the difference between the Gross enrolment ratio (%) in Primary schools in 1993 and the Gross enrolment ratio (%) in Secondary schools in 2000?
Make the answer very short. 20.14. What is the difference between the Gross enrolment ratio (%) in Primary schools in 1993 and the Gross enrolment ratio (%) in Tertiary schools in 2000?
Make the answer very short. 54.01. What is the difference between the Gross enrolment ratio (%) of Secondary schools in 1993 and the Gross enrolment ratio (%) of Tertiary schools in 2000?
Offer a very short reply. 37.29. What is the difference between the Gross enrolment ratio (%) in Pre-primary schools in 1993 and the Gross enrolment ratio (%) in Primary schools in 2001?
Provide a succinct answer. -48.8. What is the difference between the Gross enrolment ratio (%) in Pre-primary schools in 1993 and the Gross enrolment ratio (%) in Secondary schools in 2001?
Offer a very short reply. -36.06. What is the difference between the Gross enrolment ratio (%) in Pre-primary schools in 1993 and the Gross enrolment ratio (%) in Tertiary schools in 2001?
Offer a terse response. -6.6. What is the difference between the Gross enrolment ratio (%) of Primary schools in 1993 and the Gross enrolment ratio (%) of Secondary schools in 2001?
Provide a succinct answer. 21.04. What is the difference between the Gross enrolment ratio (%) of Primary schools in 1993 and the Gross enrolment ratio (%) of Tertiary schools in 2001?
Make the answer very short. 50.5. What is the difference between the Gross enrolment ratio (%) of Secondary schools in 1993 and the Gross enrolment ratio (%) of Tertiary schools in 2001?
Your answer should be very brief. 33.78. What is the difference between the Gross enrolment ratio (%) in Pre-primary schools in 1993 and the Gross enrolment ratio (%) in Primary schools in 2002?
Ensure brevity in your answer.  -42.71. What is the difference between the Gross enrolment ratio (%) in Pre-primary schools in 1993 and the Gross enrolment ratio (%) in Secondary schools in 2002?
Your response must be concise. -36.28. What is the difference between the Gross enrolment ratio (%) in Pre-primary schools in 1993 and the Gross enrolment ratio (%) in Tertiary schools in 2002?
Provide a short and direct response. -8.82. What is the difference between the Gross enrolment ratio (%) of Primary schools in 1993 and the Gross enrolment ratio (%) of Secondary schools in 2002?
Offer a very short reply. 20.83. What is the difference between the Gross enrolment ratio (%) of Primary schools in 1993 and the Gross enrolment ratio (%) of Tertiary schools in 2002?
Your response must be concise. 48.28. What is the difference between the Gross enrolment ratio (%) in Secondary schools in 1993 and the Gross enrolment ratio (%) in Tertiary schools in 2002?
Your response must be concise. 31.57. What is the difference between the Gross enrolment ratio (%) in Pre-primary schools in 1994 and the Gross enrolment ratio (%) in Primary schools in 1999?
Your response must be concise. -40.65. What is the difference between the Gross enrolment ratio (%) of Pre-primary schools in 1994 and the Gross enrolment ratio (%) of Secondary schools in 1999?
Your answer should be very brief. -40.27. What is the difference between the Gross enrolment ratio (%) in Pre-primary schools in 1994 and the Gross enrolment ratio (%) in Tertiary schools in 1999?
Offer a very short reply. -2.22. What is the difference between the Gross enrolment ratio (%) of Primary schools in 1994 and the Gross enrolment ratio (%) of Secondary schools in 1999?
Offer a very short reply. 26.22. What is the difference between the Gross enrolment ratio (%) in Primary schools in 1994 and the Gross enrolment ratio (%) in Tertiary schools in 1999?
Keep it short and to the point. 64.27. What is the difference between the Gross enrolment ratio (%) in Secondary schools in 1994 and the Gross enrolment ratio (%) in Tertiary schools in 1999?
Provide a succinct answer. 41.22. What is the difference between the Gross enrolment ratio (%) of Pre-primary schools in 1994 and the Gross enrolment ratio (%) of Primary schools in 2000?
Ensure brevity in your answer.  -40.91. What is the difference between the Gross enrolment ratio (%) in Pre-primary schools in 1994 and the Gross enrolment ratio (%) in Secondary schools in 2000?
Your answer should be very brief. -39.26. What is the difference between the Gross enrolment ratio (%) of Pre-primary schools in 1994 and the Gross enrolment ratio (%) of Tertiary schools in 2000?
Ensure brevity in your answer.  -5.39. What is the difference between the Gross enrolment ratio (%) of Primary schools in 1994 and the Gross enrolment ratio (%) of Secondary schools in 2000?
Your answer should be compact. 27.23. What is the difference between the Gross enrolment ratio (%) in Primary schools in 1994 and the Gross enrolment ratio (%) in Tertiary schools in 2000?
Offer a very short reply. 61.1. What is the difference between the Gross enrolment ratio (%) of Secondary schools in 1994 and the Gross enrolment ratio (%) of Tertiary schools in 2000?
Your answer should be very brief. 38.05. What is the difference between the Gross enrolment ratio (%) of Pre-primary schools in 1994 and the Gross enrolment ratio (%) of Primary schools in 2001?
Make the answer very short. -51.1. What is the difference between the Gross enrolment ratio (%) of Pre-primary schools in 1994 and the Gross enrolment ratio (%) of Secondary schools in 2001?
Provide a short and direct response. -38.36. What is the difference between the Gross enrolment ratio (%) in Pre-primary schools in 1994 and the Gross enrolment ratio (%) in Tertiary schools in 2001?
Make the answer very short. -8.9. What is the difference between the Gross enrolment ratio (%) of Primary schools in 1994 and the Gross enrolment ratio (%) of Secondary schools in 2001?
Your response must be concise. 28.13. What is the difference between the Gross enrolment ratio (%) in Primary schools in 1994 and the Gross enrolment ratio (%) in Tertiary schools in 2001?
Make the answer very short. 57.59. What is the difference between the Gross enrolment ratio (%) in Secondary schools in 1994 and the Gross enrolment ratio (%) in Tertiary schools in 2001?
Make the answer very short. 34.54. What is the difference between the Gross enrolment ratio (%) in Pre-primary schools in 1994 and the Gross enrolment ratio (%) in Primary schools in 2002?
Offer a very short reply. -45.01. What is the difference between the Gross enrolment ratio (%) in Pre-primary schools in 1994 and the Gross enrolment ratio (%) in Secondary schools in 2002?
Your response must be concise. -38.57. What is the difference between the Gross enrolment ratio (%) of Pre-primary schools in 1994 and the Gross enrolment ratio (%) of Tertiary schools in 2002?
Provide a short and direct response. -11.12. What is the difference between the Gross enrolment ratio (%) of Primary schools in 1994 and the Gross enrolment ratio (%) of Secondary schools in 2002?
Your answer should be very brief. 27.92. What is the difference between the Gross enrolment ratio (%) of Primary schools in 1994 and the Gross enrolment ratio (%) of Tertiary schools in 2002?
Keep it short and to the point. 55.38. What is the difference between the Gross enrolment ratio (%) in Secondary schools in 1994 and the Gross enrolment ratio (%) in Tertiary schools in 2002?
Offer a terse response. 32.32. What is the difference between the Gross enrolment ratio (%) in Pre-primary schools in 1999 and the Gross enrolment ratio (%) in Primary schools in 2000?
Offer a very short reply. -46.02. What is the difference between the Gross enrolment ratio (%) in Pre-primary schools in 1999 and the Gross enrolment ratio (%) in Secondary schools in 2000?
Offer a terse response. -44.38. What is the difference between the Gross enrolment ratio (%) in Pre-primary schools in 1999 and the Gross enrolment ratio (%) in Tertiary schools in 2000?
Your response must be concise. -10.51. What is the difference between the Gross enrolment ratio (%) in Primary schools in 1999 and the Gross enrolment ratio (%) in Secondary schools in 2000?
Offer a terse response. 1.39. What is the difference between the Gross enrolment ratio (%) of Primary schools in 1999 and the Gross enrolment ratio (%) of Tertiary schools in 2000?
Offer a very short reply. 35.26. What is the difference between the Gross enrolment ratio (%) of Secondary schools in 1999 and the Gross enrolment ratio (%) of Tertiary schools in 2000?
Your answer should be compact. 34.88. What is the difference between the Gross enrolment ratio (%) in Pre-primary schools in 1999 and the Gross enrolment ratio (%) in Primary schools in 2001?
Offer a terse response. -56.22. What is the difference between the Gross enrolment ratio (%) in Pre-primary schools in 1999 and the Gross enrolment ratio (%) in Secondary schools in 2001?
Provide a short and direct response. -43.48. What is the difference between the Gross enrolment ratio (%) in Pre-primary schools in 1999 and the Gross enrolment ratio (%) in Tertiary schools in 2001?
Provide a short and direct response. -14.02. What is the difference between the Gross enrolment ratio (%) in Primary schools in 1999 and the Gross enrolment ratio (%) in Secondary schools in 2001?
Make the answer very short. 2.29. What is the difference between the Gross enrolment ratio (%) of Primary schools in 1999 and the Gross enrolment ratio (%) of Tertiary schools in 2001?
Ensure brevity in your answer.  31.75. What is the difference between the Gross enrolment ratio (%) of Secondary schools in 1999 and the Gross enrolment ratio (%) of Tertiary schools in 2001?
Offer a very short reply. 31.37. What is the difference between the Gross enrolment ratio (%) in Pre-primary schools in 1999 and the Gross enrolment ratio (%) in Primary schools in 2002?
Your answer should be very brief. -50.13. What is the difference between the Gross enrolment ratio (%) in Pre-primary schools in 1999 and the Gross enrolment ratio (%) in Secondary schools in 2002?
Your answer should be very brief. -43.69. What is the difference between the Gross enrolment ratio (%) of Pre-primary schools in 1999 and the Gross enrolment ratio (%) of Tertiary schools in 2002?
Your answer should be very brief. -16.23. What is the difference between the Gross enrolment ratio (%) of Primary schools in 1999 and the Gross enrolment ratio (%) of Secondary schools in 2002?
Offer a very short reply. 2.08. What is the difference between the Gross enrolment ratio (%) of Primary schools in 1999 and the Gross enrolment ratio (%) of Tertiary schools in 2002?
Provide a succinct answer. 29.54. What is the difference between the Gross enrolment ratio (%) in Secondary schools in 1999 and the Gross enrolment ratio (%) in Tertiary schools in 2002?
Ensure brevity in your answer.  29.15. What is the difference between the Gross enrolment ratio (%) of Pre-primary schools in 2000 and the Gross enrolment ratio (%) of Primary schools in 2001?
Ensure brevity in your answer.  -54.8. What is the difference between the Gross enrolment ratio (%) of Pre-primary schools in 2000 and the Gross enrolment ratio (%) of Secondary schools in 2001?
Give a very brief answer. -42.06. What is the difference between the Gross enrolment ratio (%) in Pre-primary schools in 2000 and the Gross enrolment ratio (%) in Tertiary schools in 2001?
Your answer should be very brief. -12.6. What is the difference between the Gross enrolment ratio (%) of Primary schools in 2000 and the Gross enrolment ratio (%) of Secondary schools in 2001?
Offer a terse response. 2.55. What is the difference between the Gross enrolment ratio (%) in Primary schools in 2000 and the Gross enrolment ratio (%) in Tertiary schools in 2001?
Provide a short and direct response. 32.01. What is the difference between the Gross enrolment ratio (%) of Secondary schools in 2000 and the Gross enrolment ratio (%) of Tertiary schools in 2001?
Your answer should be very brief. 30.36. What is the difference between the Gross enrolment ratio (%) in Pre-primary schools in 2000 and the Gross enrolment ratio (%) in Primary schools in 2002?
Provide a short and direct response. -48.71. What is the difference between the Gross enrolment ratio (%) in Pre-primary schools in 2000 and the Gross enrolment ratio (%) in Secondary schools in 2002?
Provide a short and direct response. -42.28. What is the difference between the Gross enrolment ratio (%) in Pre-primary schools in 2000 and the Gross enrolment ratio (%) in Tertiary schools in 2002?
Your answer should be compact. -14.82. What is the difference between the Gross enrolment ratio (%) of Primary schools in 2000 and the Gross enrolment ratio (%) of Secondary schools in 2002?
Your response must be concise. 2.33. What is the difference between the Gross enrolment ratio (%) in Primary schools in 2000 and the Gross enrolment ratio (%) in Tertiary schools in 2002?
Provide a succinct answer. 29.79. What is the difference between the Gross enrolment ratio (%) in Secondary schools in 2000 and the Gross enrolment ratio (%) in Tertiary schools in 2002?
Offer a terse response. 28.14. What is the difference between the Gross enrolment ratio (%) of Pre-primary schools in 2001 and the Gross enrolment ratio (%) of Primary schools in 2002?
Your answer should be very brief. -48.91. What is the difference between the Gross enrolment ratio (%) of Pre-primary schools in 2001 and the Gross enrolment ratio (%) of Secondary schools in 2002?
Provide a succinct answer. -42.47. What is the difference between the Gross enrolment ratio (%) of Pre-primary schools in 2001 and the Gross enrolment ratio (%) of Tertiary schools in 2002?
Offer a very short reply. -15.01. What is the difference between the Gross enrolment ratio (%) in Primary schools in 2001 and the Gross enrolment ratio (%) in Secondary schools in 2002?
Your answer should be very brief. 12.53. What is the difference between the Gross enrolment ratio (%) in Primary schools in 2001 and the Gross enrolment ratio (%) in Tertiary schools in 2002?
Offer a very short reply. 39.98. What is the difference between the Gross enrolment ratio (%) of Secondary schools in 2001 and the Gross enrolment ratio (%) of Tertiary schools in 2002?
Offer a terse response. 27.24. What is the average Gross enrolment ratio (%) in Pre-primary schools per year?
Offer a terse response. 58.26. What is the average Gross enrolment ratio (%) of Primary schools per year?
Make the answer very short. 107.41. What is the average Gross enrolment ratio (%) of Secondary schools per year?
Give a very brief answer. 97.06. What is the average Gross enrolment ratio (%) in Tertiary schools per year?
Ensure brevity in your answer.  55.18. In the year 1990, what is the difference between the Gross enrolment ratio (%) in Pre-primary schools and Gross enrolment ratio (%) in Primary schools?
Provide a succinct answer. -40.82. In the year 1990, what is the difference between the Gross enrolment ratio (%) of Pre-primary schools and Gross enrolment ratio (%) of Secondary schools?
Your response must be concise. -27.65. In the year 1990, what is the difference between the Gross enrolment ratio (%) of Pre-primary schools and Gross enrolment ratio (%) of Tertiary schools?
Your answer should be compact. 24.33. In the year 1990, what is the difference between the Gross enrolment ratio (%) of Primary schools and Gross enrolment ratio (%) of Secondary schools?
Your answer should be very brief. 13.17. In the year 1990, what is the difference between the Gross enrolment ratio (%) in Primary schools and Gross enrolment ratio (%) in Tertiary schools?
Provide a short and direct response. 65.15. In the year 1990, what is the difference between the Gross enrolment ratio (%) in Secondary schools and Gross enrolment ratio (%) in Tertiary schools?
Give a very brief answer. 51.98. In the year 1991, what is the difference between the Gross enrolment ratio (%) in Pre-primary schools and Gross enrolment ratio (%) in Primary schools?
Make the answer very short. -41.21. In the year 1991, what is the difference between the Gross enrolment ratio (%) in Pre-primary schools and Gross enrolment ratio (%) in Secondary schools?
Your response must be concise. -31.39. In the year 1991, what is the difference between the Gross enrolment ratio (%) in Pre-primary schools and Gross enrolment ratio (%) in Tertiary schools?
Provide a short and direct response. 21.17. In the year 1991, what is the difference between the Gross enrolment ratio (%) of Primary schools and Gross enrolment ratio (%) of Secondary schools?
Give a very brief answer. 9.82. In the year 1991, what is the difference between the Gross enrolment ratio (%) in Primary schools and Gross enrolment ratio (%) in Tertiary schools?
Your answer should be compact. 62.38. In the year 1991, what is the difference between the Gross enrolment ratio (%) in Secondary schools and Gross enrolment ratio (%) in Tertiary schools?
Your answer should be very brief. 52.56. In the year 1992, what is the difference between the Gross enrolment ratio (%) of Pre-primary schools and Gross enrolment ratio (%) of Primary schools?
Offer a terse response. -44.58. In the year 1992, what is the difference between the Gross enrolment ratio (%) of Pre-primary schools and Gross enrolment ratio (%) of Secondary schools?
Offer a very short reply. -35.36. In the year 1992, what is the difference between the Gross enrolment ratio (%) of Pre-primary schools and Gross enrolment ratio (%) of Tertiary schools?
Your answer should be very brief. 16.07. In the year 1992, what is the difference between the Gross enrolment ratio (%) of Primary schools and Gross enrolment ratio (%) of Secondary schools?
Provide a succinct answer. 9.22. In the year 1992, what is the difference between the Gross enrolment ratio (%) of Primary schools and Gross enrolment ratio (%) of Tertiary schools?
Your answer should be compact. 60.65. In the year 1992, what is the difference between the Gross enrolment ratio (%) of Secondary schools and Gross enrolment ratio (%) of Tertiary schools?
Make the answer very short. 51.44. In the year 1993, what is the difference between the Gross enrolment ratio (%) of Pre-primary schools and Gross enrolment ratio (%) of Primary schools?
Keep it short and to the point. -57.1. In the year 1993, what is the difference between the Gross enrolment ratio (%) in Pre-primary schools and Gross enrolment ratio (%) in Secondary schools?
Provide a succinct answer. -40.39. In the year 1993, what is the difference between the Gross enrolment ratio (%) of Pre-primary schools and Gross enrolment ratio (%) of Tertiary schools?
Offer a terse response. 6.82. In the year 1993, what is the difference between the Gross enrolment ratio (%) in Primary schools and Gross enrolment ratio (%) in Secondary schools?
Ensure brevity in your answer.  16.72. In the year 1993, what is the difference between the Gross enrolment ratio (%) in Primary schools and Gross enrolment ratio (%) in Tertiary schools?
Ensure brevity in your answer.  63.92. In the year 1993, what is the difference between the Gross enrolment ratio (%) in Secondary schools and Gross enrolment ratio (%) in Tertiary schools?
Offer a terse response. 47.2. In the year 1994, what is the difference between the Gross enrolment ratio (%) of Pre-primary schools and Gross enrolment ratio (%) of Primary schools?
Ensure brevity in your answer.  -66.5. In the year 1994, what is the difference between the Gross enrolment ratio (%) of Pre-primary schools and Gross enrolment ratio (%) of Secondary schools?
Provide a succinct answer. -43.44. In the year 1994, what is the difference between the Gross enrolment ratio (%) in Pre-primary schools and Gross enrolment ratio (%) in Tertiary schools?
Your answer should be very brief. 1.46. In the year 1994, what is the difference between the Gross enrolment ratio (%) of Primary schools and Gross enrolment ratio (%) of Secondary schools?
Your answer should be compact. 23.05. In the year 1994, what is the difference between the Gross enrolment ratio (%) of Primary schools and Gross enrolment ratio (%) of Tertiary schools?
Your response must be concise. 67.96. In the year 1994, what is the difference between the Gross enrolment ratio (%) in Secondary schools and Gross enrolment ratio (%) in Tertiary schools?
Ensure brevity in your answer.  44.91. In the year 1999, what is the difference between the Gross enrolment ratio (%) in Pre-primary schools and Gross enrolment ratio (%) in Primary schools?
Your answer should be very brief. -45.77. In the year 1999, what is the difference between the Gross enrolment ratio (%) of Pre-primary schools and Gross enrolment ratio (%) of Secondary schools?
Offer a terse response. -45.39. In the year 1999, what is the difference between the Gross enrolment ratio (%) of Pre-primary schools and Gross enrolment ratio (%) of Tertiary schools?
Your answer should be very brief. -7.34. In the year 1999, what is the difference between the Gross enrolment ratio (%) of Primary schools and Gross enrolment ratio (%) of Secondary schools?
Ensure brevity in your answer.  0.38. In the year 1999, what is the difference between the Gross enrolment ratio (%) in Primary schools and Gross enrolment ratio (%) in Tertiary schools?
Ensure brevity in your answer.  38.43. In the year 1999, what is the difference between the Gross enrolment ratio (%) in Secondary schools and Gross enrolment ratio (%) in Tertiary schools?
Offer a very short reply. 38.05. In the year 2000, what is the difference between the Gross enrolment ratio (%) of Pre-primary schools and Gross enrolment ratio (%) of Primary schools?
Offer a very short reply. -44.61. In the year 2000, what is the difference between the Gross enrolment ratio (%) of Pre-primary schools and Gross enrolment ratio (%) of Secondary schools?
Your answer should be compact. -42.96. In the year 2000, what is the difference between the Gross enrolment ratio (%) of Pre-primary schools and Gross enrolment ratio (%) of Tertiary schools?
Offer a terse response. -9.09. In the year 2000, what is the difference between the Gross enrolment ratio (%) in Primary schools and Gross enrolment ratio (%) in Secondary schools?
Keep it short and to the point. 1.65. In the year 2000, what is the difference between the Gross enrolment ratio (%) in Primary schools and Gross enrolment ratio (%) in Tertiary schools?
Give a very brief answer. 35.51. In the year 2000, what is the difference between the Gross enrolment ratio (%) of Secondary schools and Gross enrolment ratio (%) of Tertiary schools?
Offer a terse response. 33.87. In the year 2001, what is the difference between the Gross enrolment ratio (%) of Pre-primary schools and Gross enrolment ratio (%) of Primary schools?
Make the answer very short. -54.99. In the year 2001, what is the difference between the Gross enrolment ratio (%) in Pre-primary schools and Gross enrolment ratio (%) in Secondary schools?
Offer a terse response. -42.25. In the year 2001, what is the difference between the Gross enrolment ratio (%) of Pre-primary schools and Gross enrolment ratio (%) of Tertiary schools?
Ensure brevity in your answer.  -12.79. In the year 2001, what is the difference between the Gross enrolment ratio (%) in Primary schools and Gross enrolment ratio (%) in Secondary schools?
Provide a succinct answer. 12.74. In the year 2001, what is the difference between the Gross enrolment ratio (%) in Primary schools and Gross enrolment ratio (%) in Tertiary schools?
Offer a very short reply. 42.2. In the year 2001, what is the difference between the Gross enrolment ratio (%) of Secondary schools and Gross enrolment ratio (%) of Tertiary schools?
Offer a very short reply. 29.46. In the year 2002, what is the difference between the Gross enrolment ratio (%) in Pre-primary schools and Gross enrolment ratio (%) in Primary schools?
Keep it short and to the point. -46.83. In the year 2002, what is the difference between the Gross enrolment ratio (%) in Pre-primary schools and Gross enrolment ratio (%) in Secondary schools?
Make the answer very short. -40.39. In the year 2002, what is the difference between the Gross enrolment ratio (%) of Pre-primary schools and Gross enrolment ratio (%) of Tertiary schools?
Provide a short and direct response. -12.93. In the year 2002, what is the difference between the Gross enrolment ratio (%) in Primary schools and Gross enrolment ratio (%) in Secondary schools?
Ensure brevity in your answer.  6.44. In the year 2002, what is the difference between the Gross enrolment ratio (%) in Primary schools and Gross enrolment ratio (%) in Tertiary schools?
Keep it short and to the point. 33.89. In the year 2002, what is the difference between the Gross enrolment ratio (%) in Secondary schools and Gross enrolment ratio (%) in Tertiary schools?
Keep it short and to the point. 27.46. What is the ratio of the Gross enrolment ratio (%) in Pre-primary schools in 1990 to that in 1991?
Offer a very short reply. 1.02. What is the ratio of the Gross enrolment ratio (%) in Primary schools in 1990 to that in 1991?
Make the answer very short. 1.01. What is the ratio of the Gross enrolment ratio (%) in Secondary schools in 1990 to that in 1991?
Give a very brief answer. 0.98. What is the ratio of the Gross enrolment ratio (%) of Tertiary schools in 1990 to that in 1991?
Offer a very short reply. 0.97. What is the ratio of the Gross enrolment ratio (%) of Pre-primary schools in 1990 to that in 1992?
Ensure brevity in your answer.  1.07. What is the ratio of the Gross enrolment ratio (%) of Primary schools in 1990 to that in 1992?
Keep it short and to the point. 1.01. What is the ratio of the Gross enrolment ratio (%) in Secondary schools in 1990 to that in 1992?
Your answer should be compact. 0.97. What is the ratio of the Gross enrolment ratio (%) of Tertiary schools in 1990 to that in 1992?
Give a very brief answer. 0.92. What is the ratio of the Gross enrolment ratio (%) in Pre-primary schools in 1990 to that in 1993?
Your answer should be compact. 1.17. What is the ratio of the Gross enrolment ratio (%) of Primary schools in 1990 to that in 1993?
Offer a terse response. 0.94. What is the ratio of the Gross enrolment ratio (%) of Secondary schools in 1990 to that in 1993?
Offer a very short reply. 0.97. What is the ratio of the Gross enrolment ratio (%) in Tertiary schools in 1990 to that in 1993?
Offer a terse response. 0.85. What is the ratio of the Gross enrolment ratio (%) of Pre-primary schools in 1990 to that in 1994?
Your answer should be very brief. 1.22. What is the ratio of the Gross enrolment ratio (%) in Primary schools in 1990 to that in 1994?
Offer a terse response. 0.89. What is the ratio of the Gross enrolment ratio (%) in Secondary schools in 1990 to that in 1994?
Your response must be concise. 0.96. What is the ratio of the Gross enrolment ratio (%) of Tertiary schools in 1990 to that in 1994?
Your answer should be compact. 0.81. What is the ratio of the Gross enrolment ratio (%) in Pre-primary schools in 1990 to that in 1999?
Provide a short and direct response. 1.34. What is the ratio of the Gross enrolment ratio (%) in Primary schools in 1990 to that in 1999?
Make the answer very short. 1.13. What is the ratio of the Gross enrolment ratio (%) in Tertiary schools in 1990 to that in 1999?
Your response must be concise. 0.75. What is the ratio of the Gross enrolment ratio (%) in Pre-primary schools in 1990 to that in 2000?
Keep it short and to the point. 1.3. What is the ratio of the Gross enrolment ratio (%) in Primary schools in 1990 to that in 2000?
Provide a succinct answer. 1.12. What is the ratio of the Gross enrolment ratio (%) of Secondary schools in 1990 to that in 2000?
Provide a short and direct response. 1.01. What is the ratio of the Gross enrolment ratio (%) of Tertiary schools in 1990 to that in 2000?
Your answer should be very brief. 0.72. What is the ratio of the Gross enrolment ratio (%) of Pre-primary schools in 1990 to that in 2001?
Provide a short and direct response. 1.31. What is the ratio of the Gross enrolment ratio (%) in Secondary schools in 1990 to that in 2001?
Offer a very short reply. 1.02. What is the ratio of the Gross enrolment ratio (%) of Tertiary schools in 1990 to that in 2001?
Make the answer very short. 0.68. What is the ratio of the Gross enrolment ratio (%) of Pre-primary schools in 1990 to that in 2002?
Provide a succinct answer. 1.26. What is the ratio of the Gross enrolment ratio (%) of Primary schools in 1990 to that in 2002?
Provide a short and direct response. 1.08. What is the ratio of the Gross enrolment ratio (%) of Secondary schools in 1990 to that in 2002?
Keep it short and to the point. 1.01. What is the ratio of the Gross enrolment ratio (%) of Tertiary schools in 1990 to that in 2002?
Ensure brevity in your answer.  0.65. What is the ratio of the Gross enrolment ratio (%) in Pre-primary schools in 1991 to that in 1992?
Ensure brevity in your answer.  1.04. What is the ratio of the Gross enrolment ratio (%) of Secondary schools in 1991 to that in 1992?
Ensure brevity in your answer.  0.99. What is the ratio of the Gross enrolment ratio (%) of Tertiary schools in 1991 to that in 1992?
Ensure brevity in your answer.  0.95. What is the ratio of the Gross enrolment ratio (%) of Pre-primary schools in 1991 to that in 1993?
Your response must be concise. 1.14. What is the ratio of the Gross enrolment ratio (%) in Primary schools in 1991 to that in 1993?
Ensure brevity in your answer.  0.93. What is the ratio of the Gross enrolment ratio (%) in Secondary schools in 1991 to that in 1993?
Offer a very short reply. 0.99. What is the ratio of the Gross enrolment ratio (%) of Tertiary schools in 1991 to that in 1993?
Offer a terse response. 0.88. What is the ratio of the Gross enrolment ratio (%) of Pre-primary schools in 1991 to that in 1994?
Give a very brief answer. 1.19. What is the ratio of the Gross enrolment ratio (%) of Primary schools in 1991 to that in 1994?
Offer a very short reply. 0.88. What is the ratio of the Gross enrolment ratio (%) in Secondary schools in 1991 to that in 1994?
Make the answer very short. 0.99. What is the ratio of the Gross enrolment ratio (%) of Tertiary schools in 1991 to that in 1994?
Offer a very short reply. 0.83. What is the ratio of the Gross enrolment ratio (%) of Pre-primary schools in 1991 to that in 1999?
Offer a terse response. 1.31. What is the ratio of the Gross enrolment ratio (%) in Primary schools in 1991 to that in 1999?
Make the answer very short. 1.12. What is the ratio of the Gross enrolment ratio (%) in Secondary schools in 1991 to that in 1999?
Your response must be concise. 1.02. What is the ratio of the Gross enrolment ratio (%) of Tertiary schools in 1991 to that in 1999?
Provide a short and direct response. 0.78. What is the ratio of the Gross enrolment ratio (%) in Pre-primary schools in 1991 to that in 2000?
Your answer should be compact. 1.27. What is the ratio of the Gross enrolment ratio (%) of Primary schools in 1991 to that in 2000?
Your answer should be compact. 1.11. What is the ratio of the Gross enrolment ratio (%) of Secondary schools in 1991 to that in 2000?
Offer a terse response. 1.03. What is the ratio of the Gross enrolment ratio (%) in Tertiary schools in 1991 to that in 2000?
Keep it short and to the point. 0.74. What is the ratio of the Gross enrolment ratio (%) in Pre-primary schools in 1991 to that in 2001?
Offer a very short reply. 1.28. What is the ratio of the Gross enrolment ratio (%) in Primary schools in 1991 to that in 2001?
Your answer should be compact. 1.01. What is the ratio of the Gross enrolment ratio (%) of Secondary schools in 1991 to that in 2001?
Provide a succinct answer. 1.04. What is the ratio of the Gross enrolment ratio (%) of Tertiary schools in 1991 to that in 2001?
Offer a very short reply. 0.7. What is the ratio of the Gross enrolment ratio (%) of Pre-primary schools in 1991 to that in 2002?
Offer a very short reply. 1.23. What is the ratio of the Gross enrolment ratio (%) in Primary schools in 1991 to that in 2002?
Offer a terse response. 1.07. What is the ratio of the Gross enrolment ratio (%) in Secondary schools in 1991 to that in 2002?
Your response must be concise. 1.04. What is the ratio of the Gross enrolment ratio (%) in Tertiary schools in 1991 to that in 2002?
Your answer should be very brief. 0.68. What is the ratio of the Gross enrolment ratio (%) in Pre-primary schools in 1992 to that in 1993?
Provide a succinct answer. 1.1. What is the ratio of the Gross enrolment ratio (%) in Secondary schools in 1992 to that in 1993?
Your response must be concise. 1.01. What is the ratio of the Gross enrolment ratio (%) in Tertiary schools in 1992 to that in 1993?
Your answer should be compact. 0.93. What is the ratio of the Gross enrolment ratio (%) in Pre-primary schools in 1992 to that in 1994?
Your response must be concise. 1.14. What is the ratio of the Gross enrolment ratio (%) in Primary schools in 1992 to that in 1994?
Make the answer very short. 0.89. What is the ratio of the Gross enrolment ratio (%) of Secondary schools in 1992 to that in 1994?
Keep it short and to the point. 1. What is the ratio of the Gross enrolment ratio (%) of Tertiary schools in 1992 to that in 1994?
Offer a terse response. 0.88. What is the ratio of the Gross enrolment ratio (%) in Pre-primary schools in 1992 to that in 1999?
Offer a terse response. 1.25. What is the ratio of the Gross enrolment ratio (%) in Primary schools in 1992 to that in 1999?
Keep it short and to the point. 1.12. What is the ratio of the Gross enrolment ratio (%) in Secondary schools in 1992 to that in 1999?
Offer a terse response. 1.03. What is the ratio of the Gross enrolment ratio (%) in Tertiary schools in 1992 to that in 1999?
Offer a terse response. 0.82. What is the ratio of the Gross enrolment ratio (%) of Pre-primary schools in 1992 to that in 2000?
Keep it short and to the point. 1.22. What is the ratio of the Gross enrolment ratio (%) in Primary schools in 1992 to that in 2000?
Provide a short and direct response. 1.12. What is the ratio of the Gross enrolment ratio (%) of Secondary schools in 1992 to that in 2000?
Provide a succinct answer. 1.04. What is the ratio of the Gross enrolment ratio (%) of Tertiary schools in 1992 to that in 2000?
Make the answer very short. 0.78. What is the ratio of the Gross enrolment ratio (%) of Pre-primary schools in 1992 to that in 2001?
Your response must be concise. 1.23. What is the ratio of the Gross enrolment ratio (%) of Primary schools in 1992 to that in 2001?
Offer a terse response. 1.01. What is the ratio of the Gross enrolment ratio (%) in Secondary schools in 1992 to that in 2001?
Your response must be concise. 1.05. What is the ratio of the Gross enrolment ratio (%) of Tertiary schools in 1992 to that in 2001?
Make the answer very short. 0.74. What is the ratio of the Gross enrolment ratio (%) in Pre-primary schools in 1992 to that in 2002?
Provide a succinct answer. 1.18. What is the ratio of the Gross enrolment ratio (%) of Primary schools in 1992 to that in 2002?
Make the answer very short. 1.07. What is the ratio of the Gross enrolment ratio (%) in Secondary schools in 1992 to that in 2002?
Your response must be concise. 1.05. What is the ratio of the Gross enrolment ratio (%) in Tertiary schools in 1992 to that in 2002?
Offer a terse response. 0.71. What is the ratio of the Gross enrolment ratio (%) of Pre-primary schools in 1993 to that in 1994?
Provide a short and direct response. 1.04. What is the ratio of the Gross enrolment ratio (%) of Primary schools in 1993 to that in 1994?
Your answer should be very brief. 0.94. What is the ratio of the Gross enrolment ratio (%) of Secondary schools in 1993 to that in 1994?
Offer a very short reply. 0.99. What is the ratio of the Gross enrolment ratio (%) of Tertiary schools in 1993 to that in 1994?
Give a very brief answer. 0.94. What is the ratio of the Gross enrolment ratio (%) of Pre-primary schools in 1993 to that in 1999?
Your answer should be very brief. 1.15. What is the ratio of the Gross enrolment ratio (%) in Primary schools in 1993 to that in 1999?
Make the answer very short. 1.19. What is the ratio of the Gross enrolment ratio (%) of Tertiary schools in 1993 to that in 1999?
Make the answer very short. 0.88. What is the ratio of the Gross enrolment ratio (%) of Pre-primary schools in 1993 to that in 2000?
Offer a very short reply. 1.11. What is the ratio of the Gross enrolment ratio (%) in Primary schools in 1993 to that in 2000?
Keep it short and to the point. 1.19. What is the ratio of the Gross enrolment ratio (%) in Secondary schools in 1993 to that in 2000?
Provide a succinct answer. 1.04. What is the ratio of the Gross enrolment ratio (%) of Tertiary schools in 1993 to that in 2000?
Keep it short and to the point. 0.84. What is the ratio of the Gross enrolment ratio (%) of Pre-primary schools in 1993 to that in 2001?
Your response must be concise. 1.12. What is the ratio of the Gross enrolment ratio (%) in Primary schools in 1993 to that in 2001?
Provide a succinct answer. 1.08. What is the ratio of the Gross enrolment ratio (%) of Secondary schools in 1993 to that in 2001?
Offer a very short reply. 1.05. What is the ratio of the Gross enrolment ratio (%) in Tertiary schools in 1993 to that in 2001?
Your answer should be very brief. 0.79. What is the ratio of the Gross enrolment ratio (%) of Pre-primary schools in 1993 to that in 2002?
Provide a succinct answer. 1.08. What is the ratio of the Gross enrolment ratio (%) in Primary schools in 1993 to that in 2002?
Ensure brevity in your answer.  1.14. What is the ratio of the Gross enrolment ratio (%) in Secondary schools in 1993 to that in 2002?
Offer a terse response. 1.04. What is the ratio of the Gross enrolment ratio (%) in Tertiary schools in 1993 to that in 2002?
Your answer should be compact. 0.77. What is the ratio of the Gross enrolment ratio (%) in Pre-primary schools in 1994 to that in 1999?
Your answer should be compact. 1.1. What is the ratio of the Gross enrolment ratio (%) of Primary schools in 1994 to that in 1999?
Your response must be concise. 1.27. What is the ratio of the Gross enrolment ratio (%) of Secondary schools in 1994 to that in 1999?
Provide a short and direct response. 1.03. What is the ratio of the Gross enrolment ratio (%) in Tertiary schools in 1994 to that in 1999?
Keep it short and to the point. 0.94. What is the ratio of the Gross enrolment ratio (%) in Pre-primary schools in 1994 to that in 2000?
Offer a very short reply. 1.07. What is the ratio of the Gross enrolment ratio (%) of Primary schools in 1994 to that in 2000?
Your response must be concise. 1.26. What is the ratio of the Gross enrolment ratio (%) in Secondary schools in 1994 to that in 2000?
Offer a very short reply. 1.04. What is the ratio of the Gross enrolment ratio (%) of Tertiary schools in 1994 to that in 2000?
Keep it short and to the point. 0.89. What is the ratio of the Gross enrolment ratio (%) in Pre-primary schools in 1994 to that in 2001?
Make the answer very short. 1.07. What is the ratio of the Gross enrolment ratio (%) in Primary schools in 1994 to that in 2001?
Offer a terse response. 1.14. What is the ratio of the Gross enrolment ratio (%) in Secondary schools in 1994 to that in 2001?
Make the answer very short. 1.05. What is the ratio of the Gross enrolment ratio (%) in Tertiary schools in 1994 to that in 2001?
Your answer should be compact. 0.84. What is the ratio of the Gross enrolment ratio (%) of Pre-primary schools in 1994 to that in 2002?
Offer a terse response. 1.03. What is the ratio of the Gross enrolment ratio (%) in Primary schools in 1994 to that in 2002?
Offer a very short reply. 1.21. What is the ratio of the Gross enrolment ratio (%) in Secondary schools in 1994 to that in 2002?
Keep it short and to the point. 1.05. What is the ratio of the Gross enrolment ratio (%) of Tertiary schools in 1994 to that in 2002?
Give a very brief answer. 0.81. What is the ratio of the Gross enrolment ratio (%) of Pre-primary schools in 1999 to that in 2000?
Offer a very short reply. 0.97. What is the ratio of the Gross enrolment ratio (%) in Primary schools in 1999 to that in 2000?
Your answer should be very brief. 1. What is the ratio of the Gross enrolment ratio (%) of Secondary schools in 1999 to that in 2000?
Give a very brief answer. 1.01. What is the ratio of the Gross enrolment ratio (%) of Tertiary schools in 1999 to that in 2000?
Provide a succinct answer. 0.95. What is the ratio of the Gross enrolment ratio (%) of Pre-primary schools in 1999 to that in 2001?
Offer a very short reply. 0.98. What is the ratio of the Gross enrolment ratio (%) in Primary schools in 1999 to that in 2001?
Provide a short and direct response. 0.9. What is the ratio of the Gross enrolment ratio (%) of Secondary schools in 1999 to that in 2001?
Offer a very short reply. 1.02. What is the ratio of the Gross enrolment ratio (%) of Tertiary schools in 1999 to that in 2001?
Offer a terse response. 0.9. What is the ratio of the Gross enrolment ratio (%) of Pre-primary schools in 1999 to that in 2002?
Offer a terse response. 0.94. What is the ratio of the Gross enrolment ratio (%) in Primary schools in 1999 to that in 2002?
Your answer should be very brief. 0.96. What is the ratio of the Gross enrolment ratio (%) of Secondary schools in 1999 to that in 2002?
Offer a terse response. 1.02. What is the ratio of the Gross enrolment ratio (%) of Tertiary schools in 1999 to that in 2002?
Offer a terse response. 0.87. What is the ratio of the Gross enrolment ratio (%) of Primary schools in 2000 to that in 2001?
Provide a short and direct response. 0.91. What is the ratio of the Gross enrolment ratio (%) of Secondary schools in 2000 to that in 2001?
Keep it short and to the point. 1.01. What is the ratio of the Gross enrolment ratio (%) in Tertiary schools in 2000 to that in 2001?
Keep it short and to the point. 0.95. What is the ratio of the Gross enrolment ratio (%) of Pre-primary schools in 2000 to that in 2002?
Your answer should be very brief. 0.97. What is the ratio of the Gross enrolment ratio (%) of Primary schools in 2000 to that in 2002?
Your answer should be very brief. 0.96. What is the ratio of the Gross enrolment ratio (%) of Tertiary schools in 2000 to that in 2002?
Offer a terse response. 0.92. What is the ratio of the Gross enrolment ratio (%) of Pre-primary schools in 2001 to that in 2002?
Make the answer very short. 0.96. What is the ratio of the Gross enrolment ratio (%) of Primary schools in 2001 to that in 2002?
Keep it short and to the point. 1.06. What is the ratio of the Gross enrolment ratio (%) in Secondary schools in 2001 to that in 2002?
Keep it short and to the point. 1. What is the ratio of the Gross enrolment ratio (%) in Tertiary schools in 2001 to that in 2002?
Keep it short and to the point. 0.97. What is the difference between the highest and the second highest Gross enrolment ratio (%) in Pre-primary schools?
Provide a short and direct response. 1.62. What is the difference between the highest and the second highest Gross enrolment ratio (%) of Primary schools?
Offer a very short reply. 7.09. What is the difference between the highest and the second highest Gross enrolment ratio (%) in Secondary schools?
Your answer should be very brief. 0.19. What is the difference between the highest and the second highest Gross enrolment ratio (%) in Tertiary schools?
Keep it short and to the point. 2.22. What is the difference between the highest and the lowest Gross enrolment ratio (%) of Pre-primary schools?
Keep it short and to the point. 17.33. What is the difference between the highest and the lowest Gross enrolment ratio (%) of Primary schools?
Your answer should be very brief. 25.84. What is the difference between the highest and the lowest Gross enrolment ratio (%) in Secondary schools?
Ensure brevity in your answer.  5.08. What is the difference between the highest and the lowest Gross enrolment ratio (%) of Tertiary schools?
Offer a terse response. 23.23. 